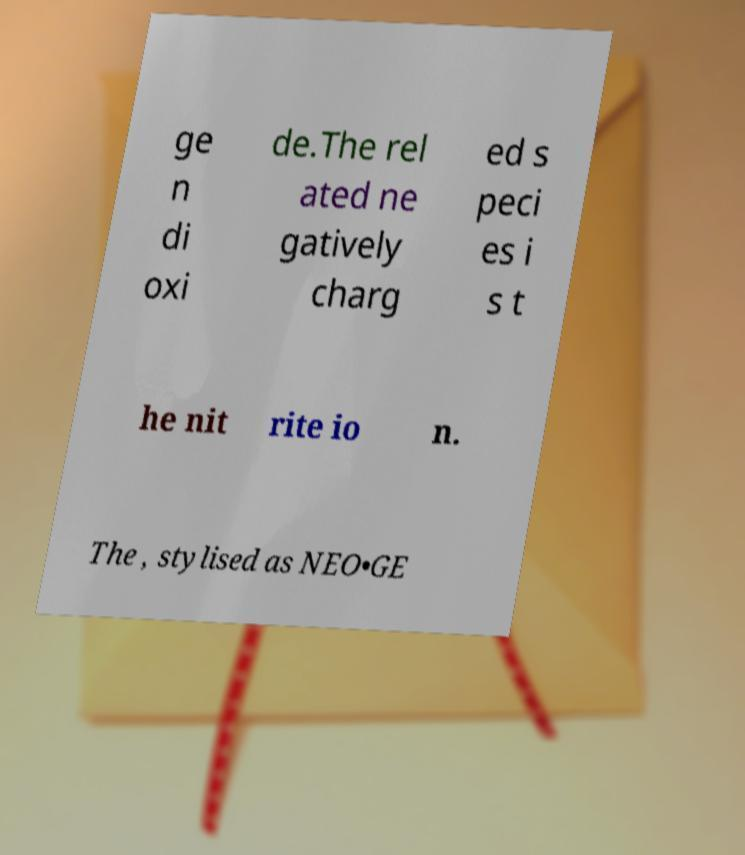Can you read and provide the text displayed in the image?This photo seems to have some interesting text. Can you extract and type it out for me? ge n di oxi de.The rel ated ne gatively charg ed s peci es i s t he nit rite io n. The , stylised as NEO•GE 